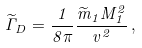<formula> <loc_0><loc_0><loc_500><loc_500>\widetilde { \Gamma } _ { D } = \frac { 1 } { 8 \pi } \frac { \widetilde { m } _ { 1 } M _ { 1 } ^ { 2 } } { v ^ { 2 } } \, ,</formula> 